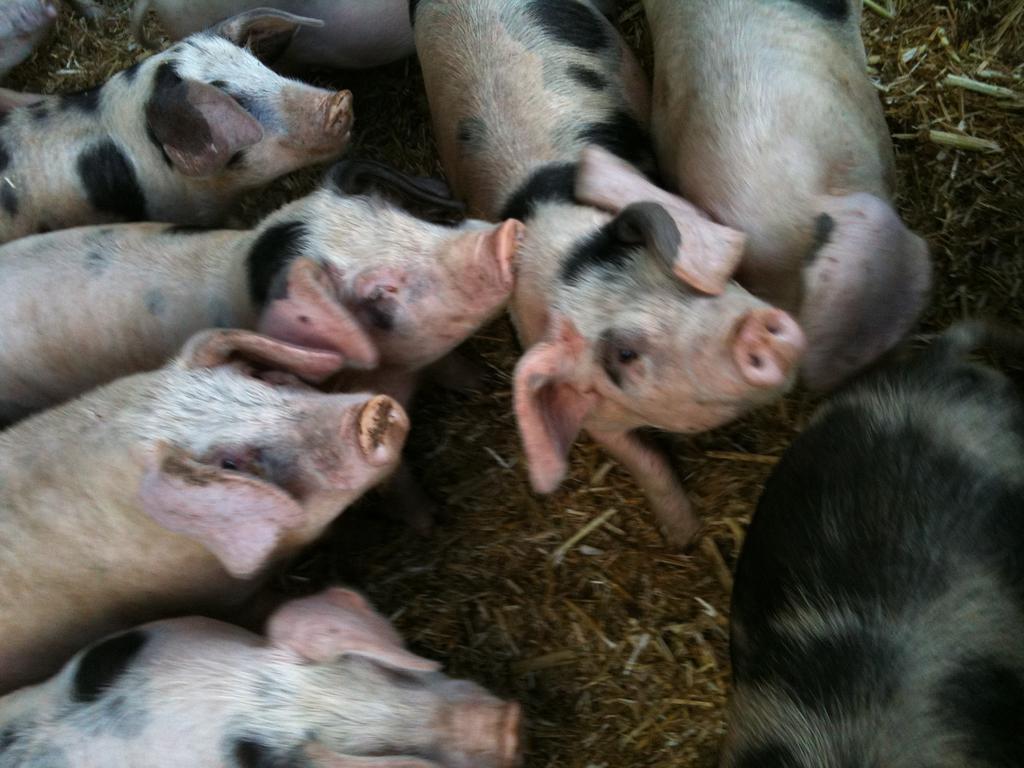How would you summarize this image in a sentence or two? In this image there are pigs on the surface of the grass. 